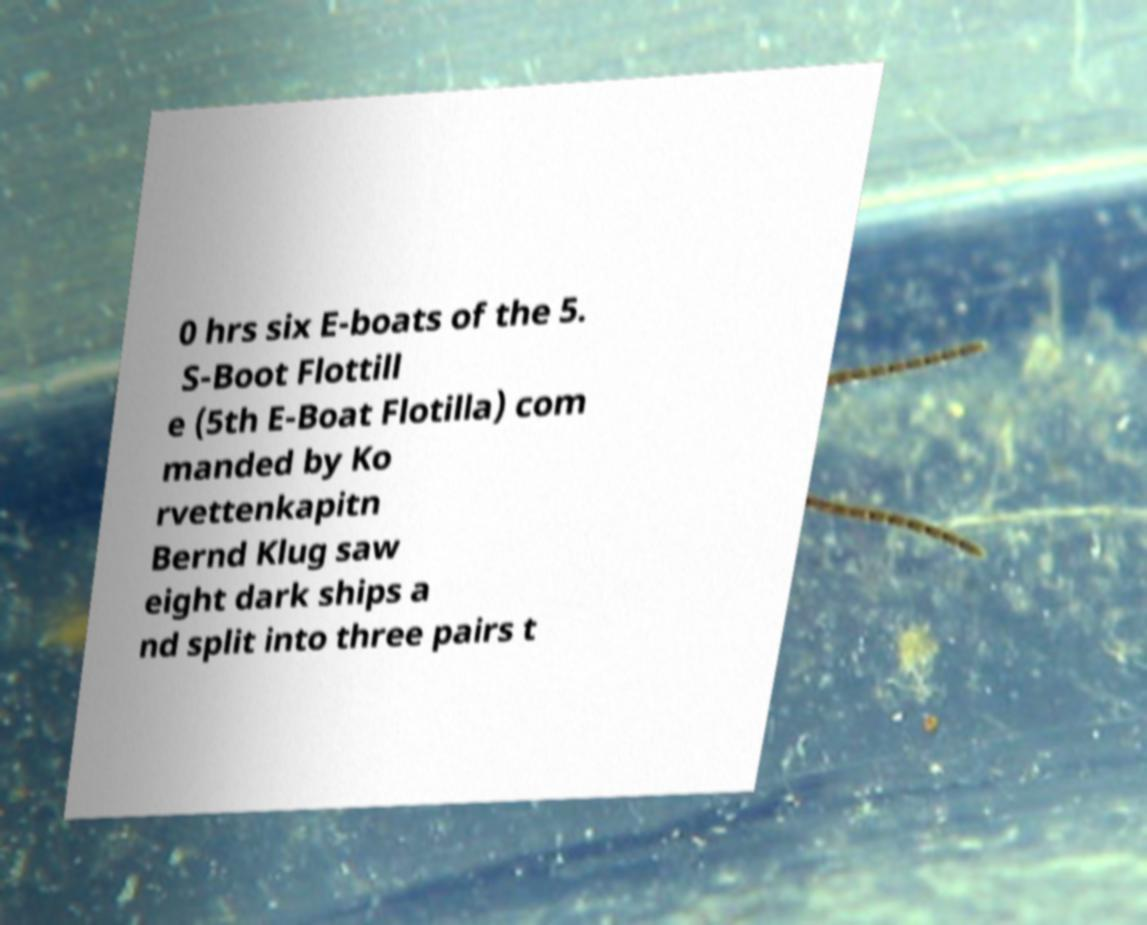Can you accurately transcribe the text from the provided image for me? 0 hrs six E-boats of the 5. S-Boot Flottill e (5th E-Boat Flotilla) com manded by Ko rvettenkapitn Bernd Klug saw eight dark ships a nd split into three pairs t 